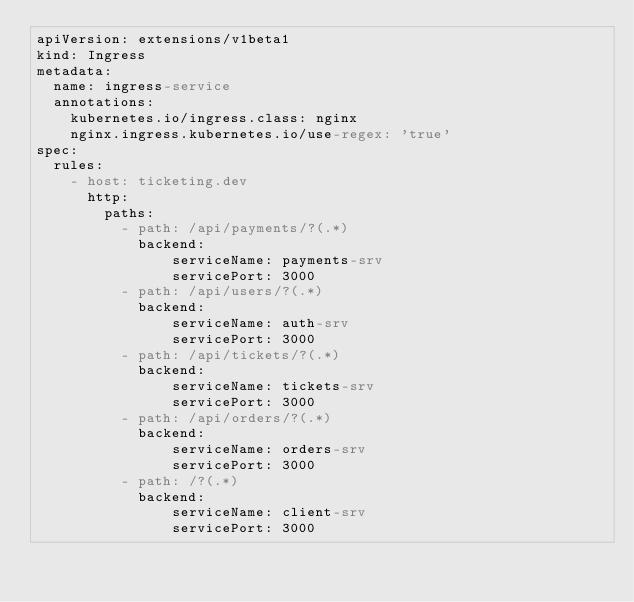Convert code to text. <code><loc_0><loc_0><loc_500><loc_500><_YAML_>apiVersion: extensions/v1beta1
kind: Ingress
metadata:
  name: ingress-service
  annotations: 
    kubernetes.io/ingress.class: nginx
    nginx.ingress.kubernetes.io/use-regex: 'true'
spec:
  rules:
    - host: ticketing.dev
      http: 
        paths:
          - path: /api/payments/?(.*)
            backend:
                serviceName: payments-srv
                servicePort: 3000
          - path: /api/users/?(.*)
            backend:
                serviceName: auth-srv
                servicePort: 3000
          - path: /api/tickets/?(.*)
            backend:
                serviceName: tickets-srv
                servicePort: 3000
          - path: /api/orders/?(.*)
            backend:
                serviceName: orders-srv
                servicePort: 3000
          - path: /?(.*)
            backend:
                serviceName: client-srv
                servicePort: 3000</code> 